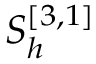Convert formula to latex. <formula><loc_0><loc_0><loc_500><loc_500>S _ { h } ^ { [ 3 , 1 ] }</formula> 